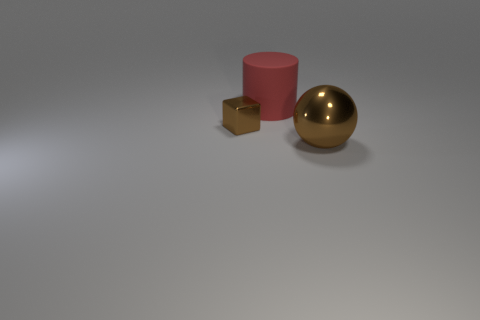Add 1 matte cylinders. How many objects exist? 4 Subtract all cylinders. How many objects are left? 2 Subtract all small red matte balls. Subtract all matte objects. How many objects are left? 2 Add 1 brown balls. How many brown balls are left? 2 Add 2 metallic blocks. How many metallic blocks exist? 3 Subtract 1 brown cubes. How many objects are left? 2 